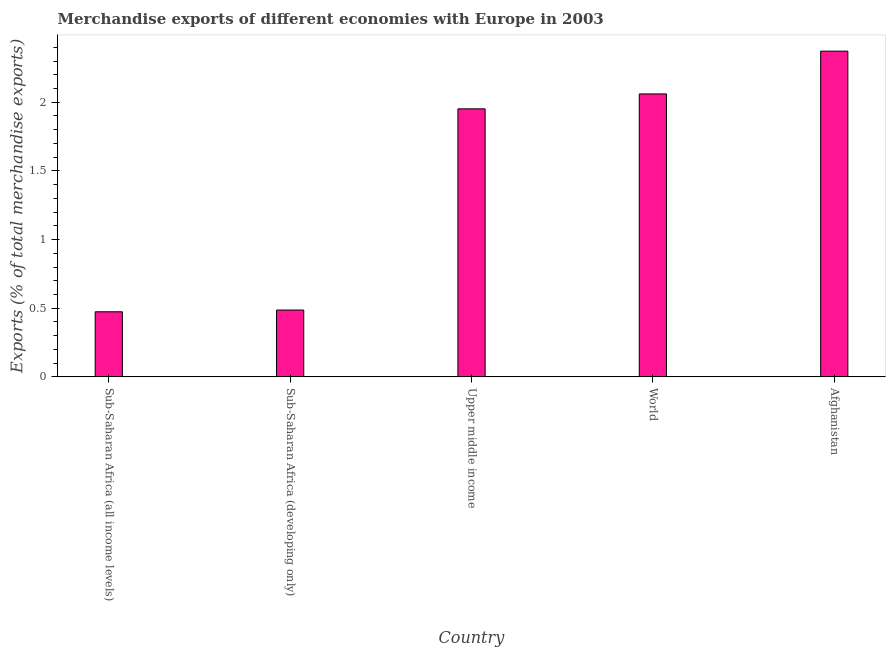Does the graph contain any zero values?
Your answer should be compact. No. What is the title of the graph?
Make the answer very short. Merchandise exports of different economies with Europe in 2003. What is the label or title of the X-axis?
Provide a succinct answer. Country. What is the label or title of the Y-axis?
Your response must be concise. Exports (% of total merchandise exports). What is the merchandise exports in Upper middle income?
Give a very brief answer. 1.95. Across all countries, what is the maximum merchandise exports?
Give a very brief answer. 2.37. Across all countries, what is the minimum merchandise exports?
Offer a terse response. 0.47. In which country was the merchandise exports maximum?
Offer a very short reply. Afghanistan. In which country was the merchandise exports minimum?
Give a very brief answer. Sub-Saharan Africa (all income levels). What is the sum of the merchandise exports?
Your answer should be very brief. 7.34. What is the difference between the merchandise exports in Afghanistan and Sub-Saharan Africa (all income levels)?
Make the answer very short. 1.9. What is the average merchandise exports per country?
Make the answer very short. 1.47. What is the median merchandise exports?
Your response must be concise. 1.95. In how many countries, is the merchandise exports greater than 0.8 %?
Provide a succinct answer. 3. What is the ratio of the merchandise exports in Afghanistan to that in Upper middle income?
Your answer should be compact. 1.22. Is the merchandise exports in Sub-Saharan Africa (all income levels) less than that in World?
Offer a terse response. Yes. Is the difference between the merchandise exports in Sub-Saharan Africa (developing only) and World greater than the difference between any two countries?
Offer a very short reply. No. What is the difference between the highest and the second highest merchandise exports?
Provide a short and direct response. 0.31. Is the sum of the merchandise exports in Sub-Saharan Africa (all income levels) and Sub-Saharan Africa (developing only) greater than the maximum merchandise exports across all countries?
Offer a terse response. No. What is the Exports (% of total merchandise exports) of Sub-Saharan Africa (all income levels)?
Your answer should be compact. 0.47. What is the Exports (% of total merchandise exports) of Sub-Saharan Africa (developing only)?
Give a very brief answer. 0.49. What is the Exports (% of total merchandise exports) of Upper middle income?
Give a very brief answer. 1.95. What is the Exports (% of total merchandise exports) in World?
Offer a very short reply. 2.06. What is the Exports (% of total merchandise exports) in Afghanistan?
Provide a short and direct response. 2.37. What is the difference between the Exports (% of total merchandise exports) in Sub-Saharan Africa (all income levels) and Sub-Saharan Africa (developing only)?
Give a very brief answer. -0.01. What is the difference between the Exports (% of total merchandise exports) in Sub-Saharan Africa (all income levels) and Upper middle income?
Your answer should be compact. -1.48. What is the difference between the Exports (% of total merchandise exports) in Sub-Saharan Africa (all income levels) and World?
Provide a short and direct response. -1.59. What is the difference between the Exports (% of total merchandise exports) in Sub-Saharan Africa (all income levels) and Afghanistan?
Keep it short and to the point. -1.9. What is the difference between the Exports (% of total merchandise exports) in Sub-Saharan Africa (developing only) and Upper middle income?
Make the answer very short. -1.47. What is the difference between the Exports (% of total merchandise exports) in Sub-Saharan Africa (developing only) and World?
Keep it short and to the point. -1.57. What is the difference between the Exports (% of total merchandise exports) in Sub-Saharan Africa (developing only) and Afghanistan?
Your response must be concise. -1.89. What is the difference between the Exports (% of total merchandise exports) in Upper middle income and World?
Give a very brief answer. -0.11. What is the difference between the Exports (% of total merchandise exports) in Upper middle income and Afghanistan?
Offer a very short reply. -0.42. What is the difference between the Exports (% of total merchandise exports) in World and Afghanistan?
Give a very brief answer. -0.31. What is the ratio of the Exports (% of total merchandise exports) in Sub-Saharan Africa (all income levels) to that in Upper middle income?
Ensure brevity in your answer.  0.24. What is the ratio of the Exports (% of total merchandise exports) in Sub-Saharan Africa (all income levels) to that in World?
Give a very brief answer. 0.23. What is the ratio of the Exports (% of total merchandise exports) in Sub-Saharan Africa (all income levels) to that in Afghanistan?
Make the answer very short. 0.2. What is the ratio of the Exports (% of total merchandise exports) in Sub-Saharan Africa (developing only) to that in Upper middle income?
Provide a short and direct response. 0.25. What is the ratio of the Exports (% of total merchandise exports) in Sub-Saharan Africa (developing only) to that in World?
Ensure brevity in your answer.  0.24. What is the ratio of the Exports (% of total merchandise exports) in Sub-Saharan Africa (developing only) to that in Afghanistan?
Offer a terse response. 0.2. What is the ratio of the Exports (% of total merchandise exports) in Upper middle income to that in World?
Ensure brevity in your answer.  0.95. What is the ratio of the Exports (% of total merchandise exports) in Upper middle income to that in Afghanistan?
Your answer should be very brief. 0.82. What is the ratio of the Exports (% of total merchandise exports) in World to that in Afghanistan?
Ensure brevity in your answer.  0.87. 